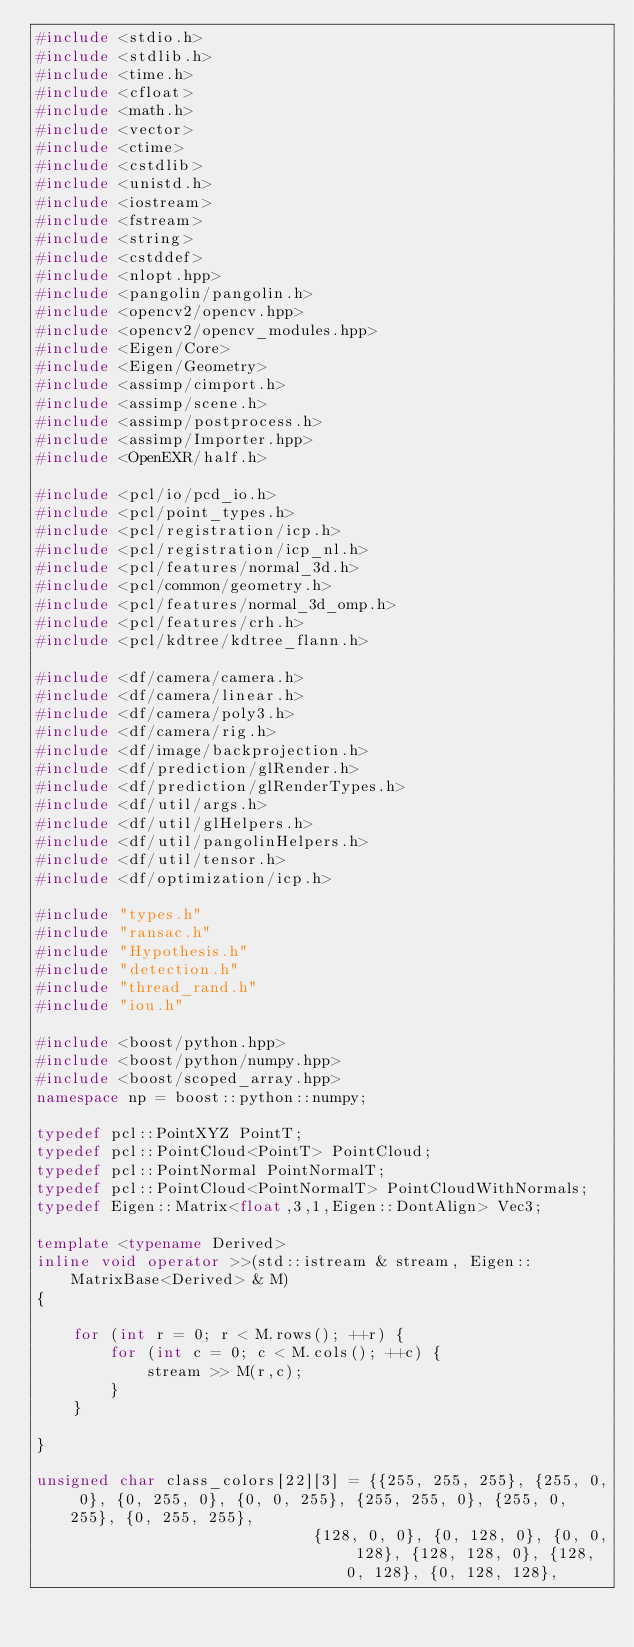<code> <loc_0><loc_0><loc_500><loc_500><_C++_>#include <stdio.h>
#include <stdlib.h>
#include <time.h>
#include <cfloat>
#include <math.h> 
#include <vector>
#include <ctime>
#include <cstdlib>
#include <unistd.h>
#include <iostream>
#include <fstream>
#include <string>
#include <cstddef> 
#include <nlopt.hpp>
#include <pangolin/pangolin.h>
#include <opencv2/opencv.hpp>
#include <opencv2/opencv_modules.hpp>
#include <Eigen/Core>
#include <Eigen/Geometry>
#include <assimp/cimport.h>
#include <assimp/scene.h>
#include <assimp/postprocess.h>
#include <assimp/Importer.hpp>
#include <OpenEXR/half.h>

#include <pcl/io/pcd_io.h>
#include <pcl/point_types.h>
#include <pcl/registration/icp.h>
#include <pcl/registration/icp_nl.h>
#include <pcl/features/normal_3d.h>
#include <pcl/common/geometry.h>
#include <pcl/features/normal_3d_omp.h>
#include <pcl/features/crh.h>
#include <pcl/kdtree/kdtree_flann.h>

#include <df/camera/camera.h>
#include <df/camera/linear.h>
#include <df/camera/poly3.h>
#include <df/camera/rig.h>
#include <df/image/backprojection.h>
#include <df/prediction/glRender.h>
#include <df/prediction/glRenderTypes.h>
#include <df/util/args.h>
#include <df/util/glHelpers.h>
#include <df/util/pangolinHelpers.h>
#include <df/util/tensor.h>
#include <df/optimization/icp.h>

#include "types.h"
#include "ransac.h"
#include "Hypothesis.h"
#include "detection.h"
#include "thread_rand.h"
#include "iou.h"

#include <boost/python.hpp>
#include <boost/python/numpy.hpp>
#include <boost/scoped_array.hpp>
namespace np = boost::python::numpy;

typedef pcl::PointXYZ PointT;
typedef pcl::PointCloud<PointT> PointCloud;
typedef pcl::PointNormal PointNormalT;
typedef pcl::PointCloud<PointNormalT> PointCloudWithNormals;
typedef Eigen::Matrix<float,3,1,Eigen::DontAlign> Vec3;

template <typename Derived>
inline void operator >>(std::istream & stream, Eigen::MatrixBase<Derived> & M)
{

    for (int r = 0; r < M.rows(); ++r) {
        for (int c = 0; c < M.cols(); ++c) {
            stream >> M(r,c);
        }
    }

}

unsigned char class_colors[22][3] = {{255, 255, 255}, {255, 0, 0}, {0, 255, 0}, {0, 0, 255}, {255, 255, 0}, {255, 0, 255}, {0, 255, 255},
                              {128, 0, 0}, {0, 128, 0}, {0, 0, 128}, {128, 128, 0}, {128, 0, 128}, {0, 128, 128},</code> 